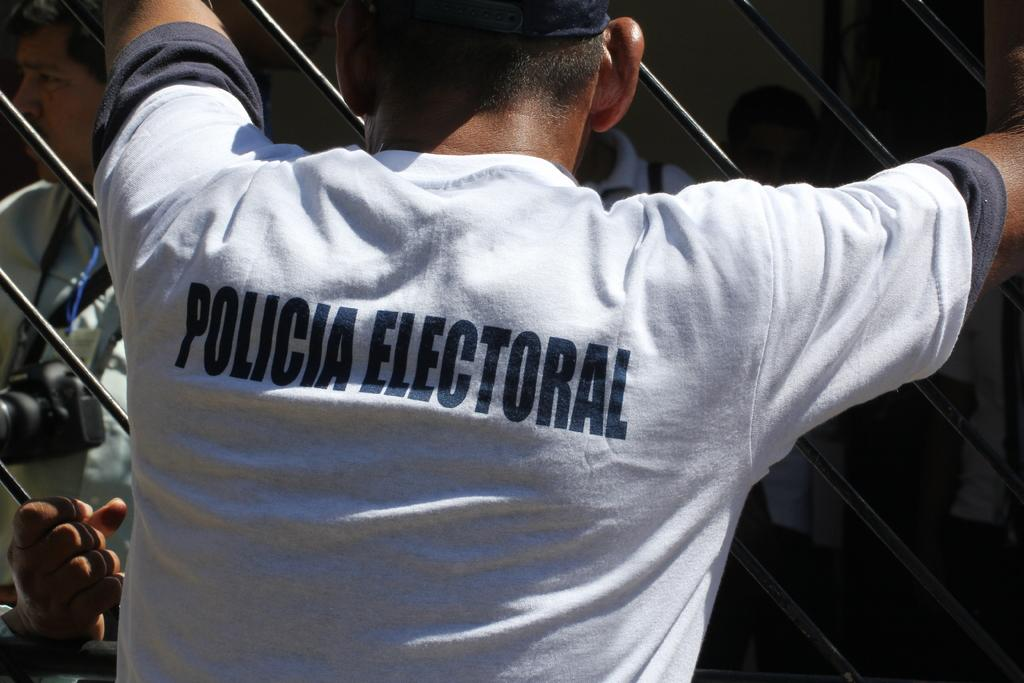<image>
Relay a brief, clear account of the picture shown. a man with a policia shirt on him 